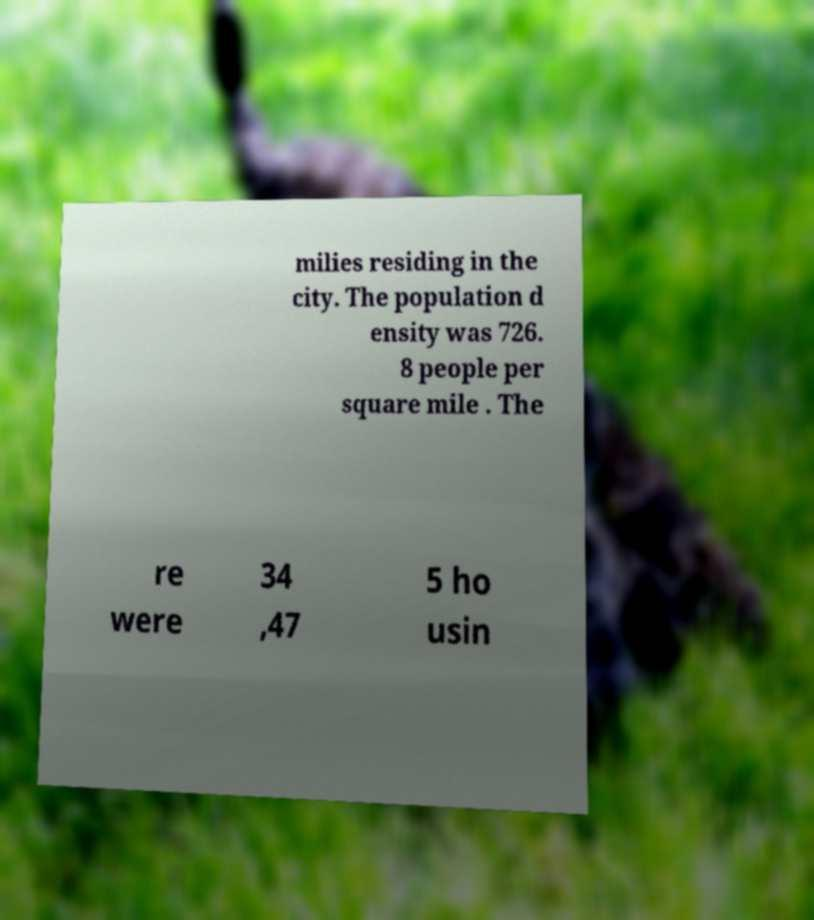Please identify and transcribe the text found in this image. milies residing in the city. The population d ensity was 726. 8 people per square mile . The re were 34 ,47 5 ho usin 